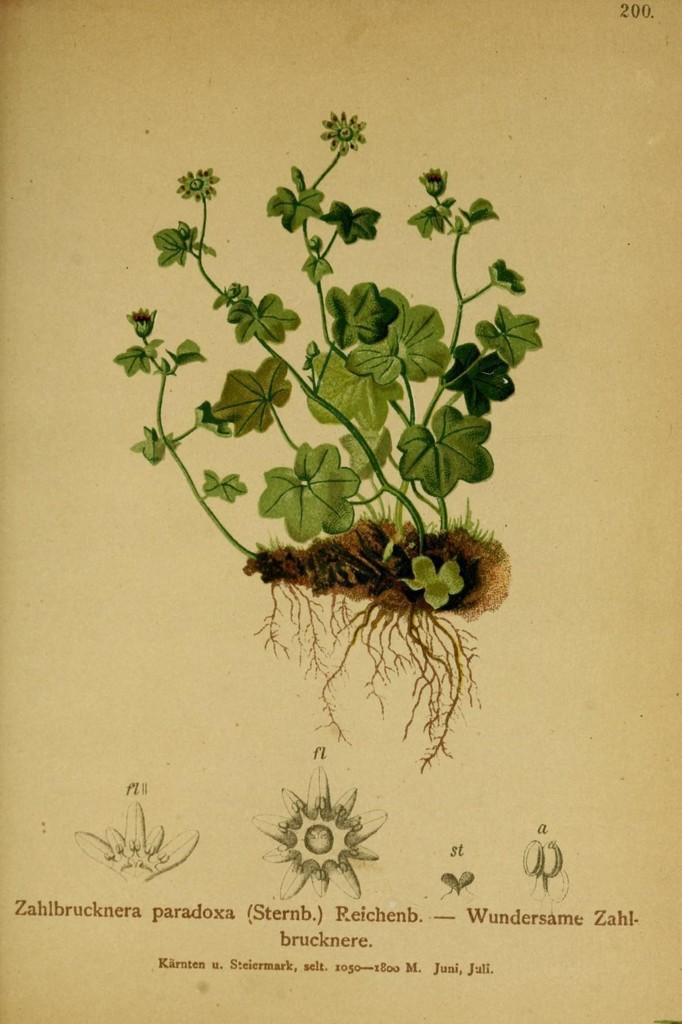Please provide a concise description of this image. On this paper we can see a picture of plant and roots. Something written on this paper. Bottom of the image we can see some drawings. 